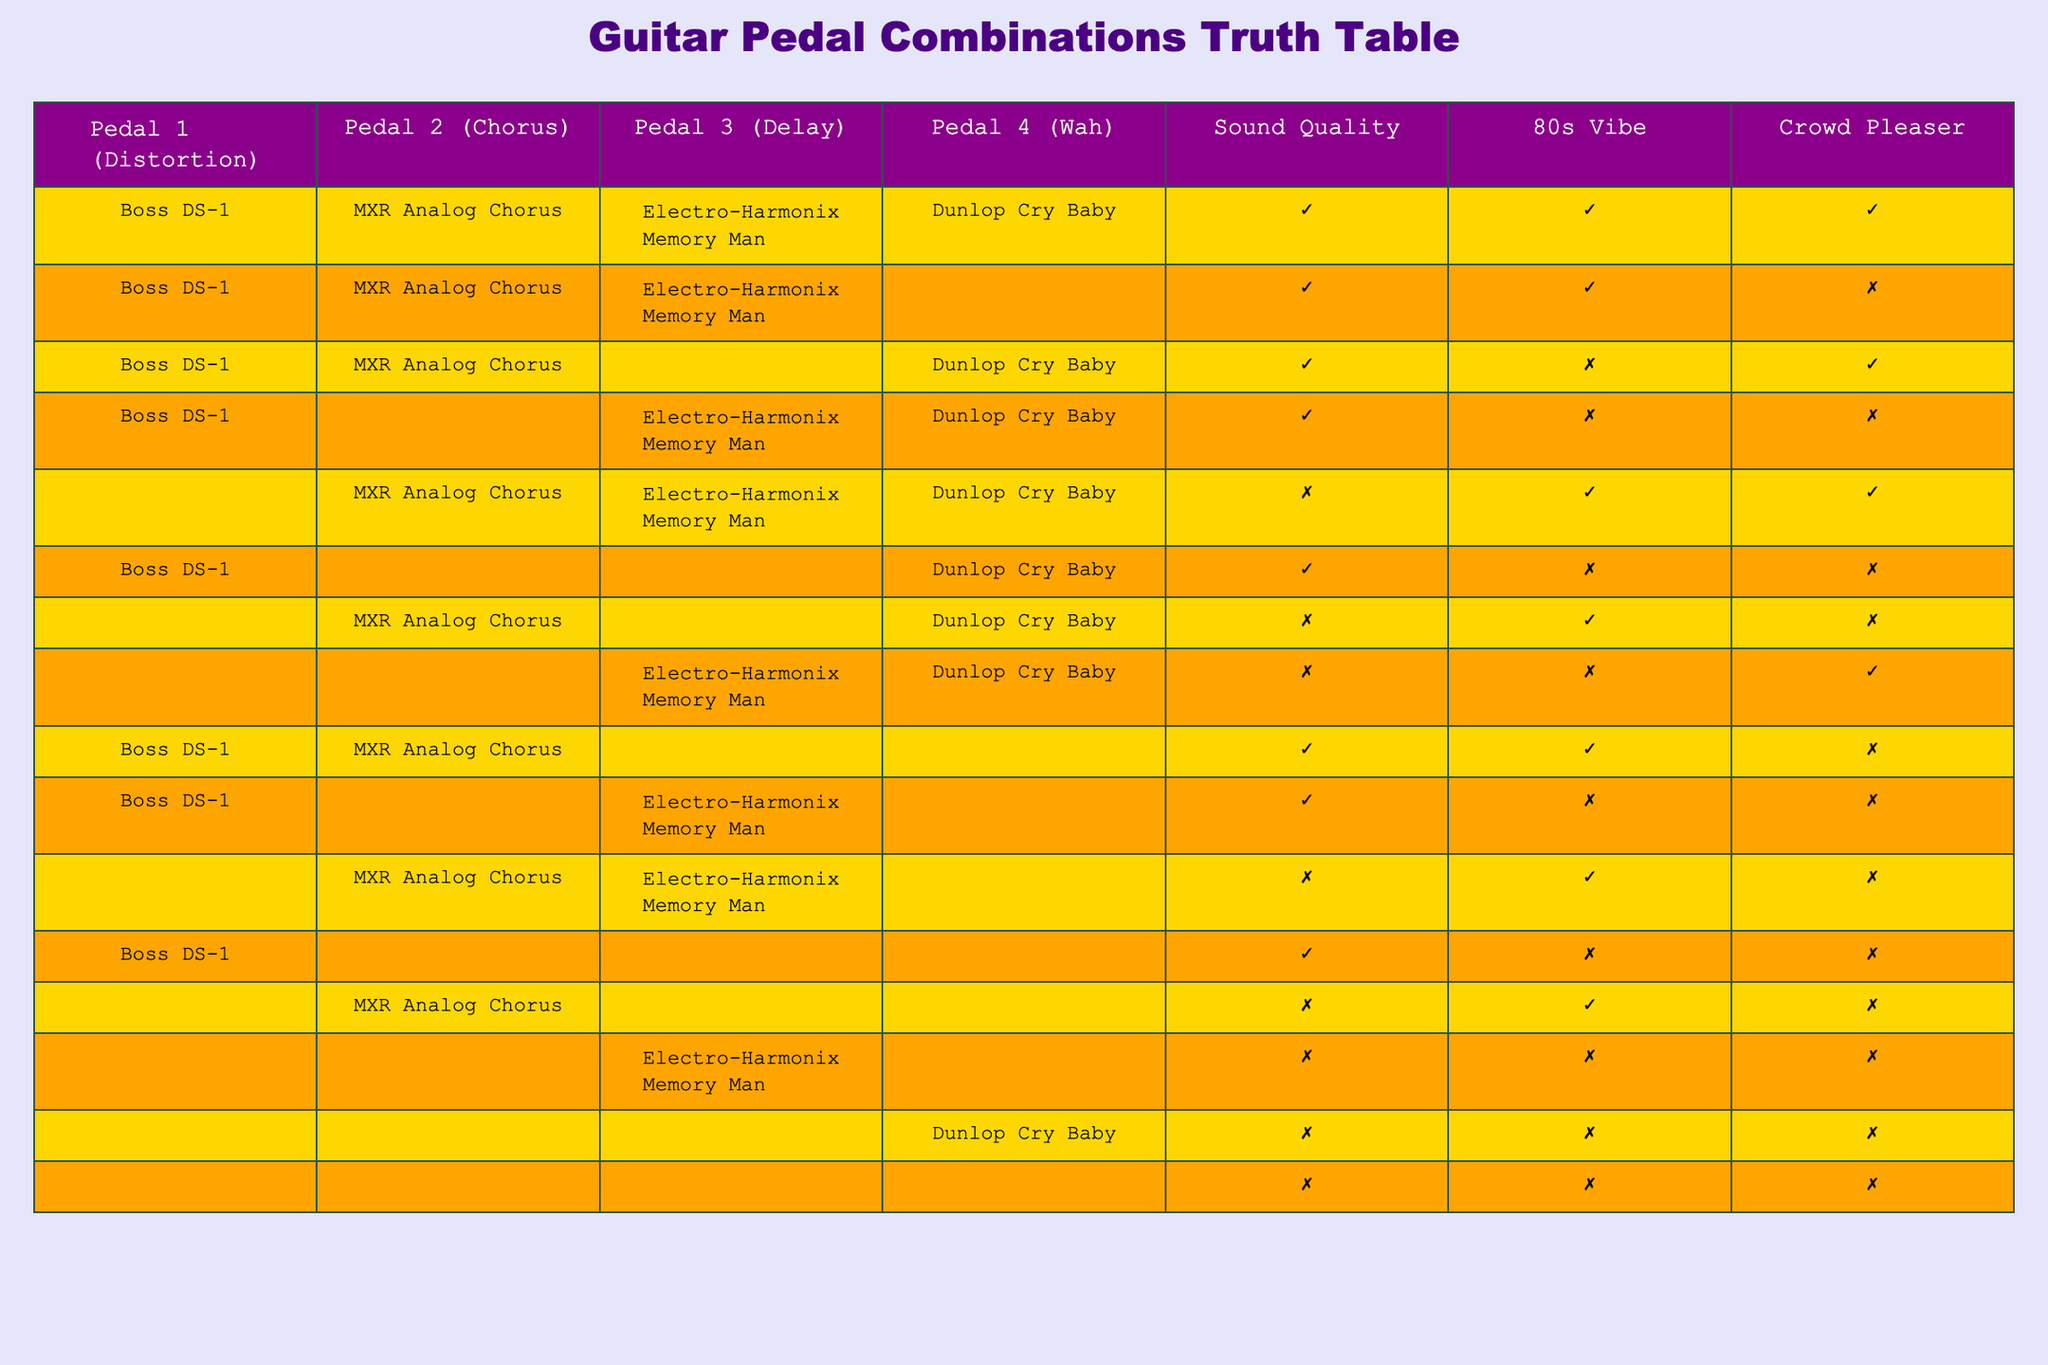What is the sound quality of the combination with Boss DS-1, MXR Analog Chorus, Electro-Harmonix Memory Man, and Dunlop Cry Baby? From the table, this specific combination (first row) has a sound quality value of True.
Answer: True Are any combinations with no pedals used associated with a sound quality of True? The rows where "None" is listed for all pedals have sound quality marked as False. Therefore, no combinations with no pedals result in a sound quality of True.
Answer: No How many combinations yield a "Crowd Pleaser" outcome? By counting the instances of True in the Crowd Pleaser column, we find that there are two combinations (first and third rows) that are crowd pleasers.
Answer: 2 What can you say about the 80s vibe of combinations that include a Wah pedal? Examining the rows with a Wah pedal, only one combination (first row) has an 80s vibe marked as True; others are False.
Answer: 1 (True) Is a combination with the Boss DS-1 and no other pedals always a "Crowd Pleaser"? Looking at the row with Boss DS-1, none, and Dunlop Cry Baby, the crowd pleaser status is False; hence it is not always one.
Answer: No What is the average sound quality for combinations that include both the Chorus and Delay pedals? There are three relevant combinations (second, fifth, and tenth rows) where sound quality is True for the second and third row, leading to an average value of 1.67 when considering True as 1 and False as 0, thus there's a 67% occurrence of sound quality as True.
Answer: 67% How many different sound qualities are there in total? There are only two distinct outcomes — True and False, as indicated by the binary nature of sound quality values.
Answer: 2 Which pedal combination yielded the worst sound quality? By comparing all combinations based on sound quality, the combinations that feature only None or produce a False sound quality indicate the worst scenarios, confirming the bottom row as an example of the worst quality.
Answer: None (False for all) 